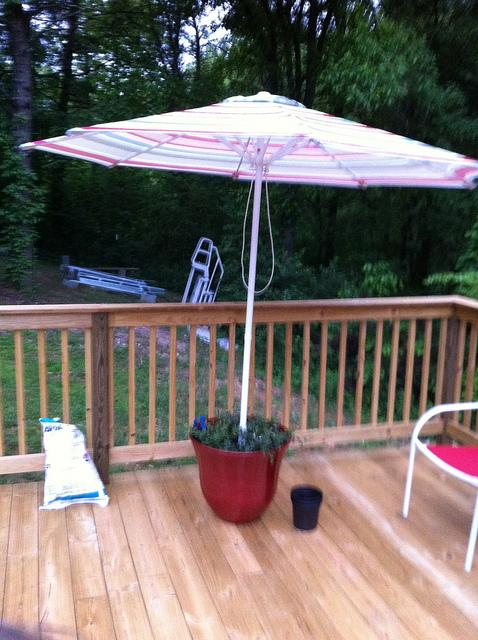What is inside the flower pot? flowers 